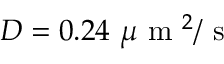<formula> <loc_0><loc_0><loc_500><loc_500>D = 0 . 2 4 \mu m ^ { 2 } / s</formula> 